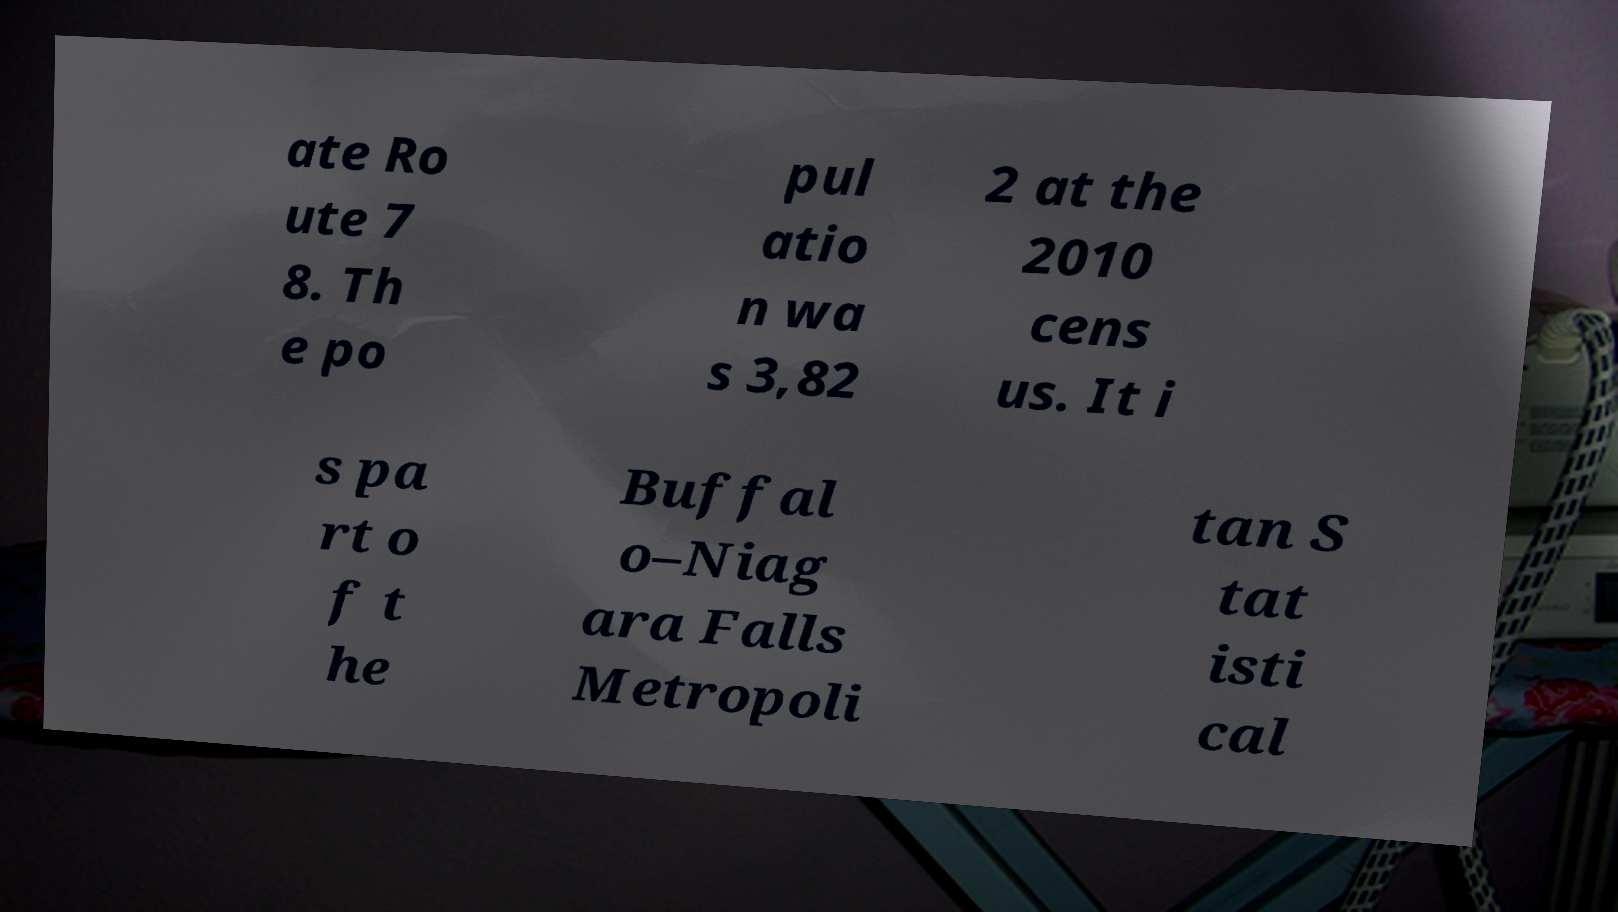Can you read and provide the text displayed in the image?This photo seems to have some interesting text. Can you extract and type it out for me? ate Ro ute 7 8. Th e po pul atio n wa s 3,82 2 at the 2010 cens us. It i s pa rt o f t he Buffal o–Niag ara Falls Metropoli tan S tat isti cal 